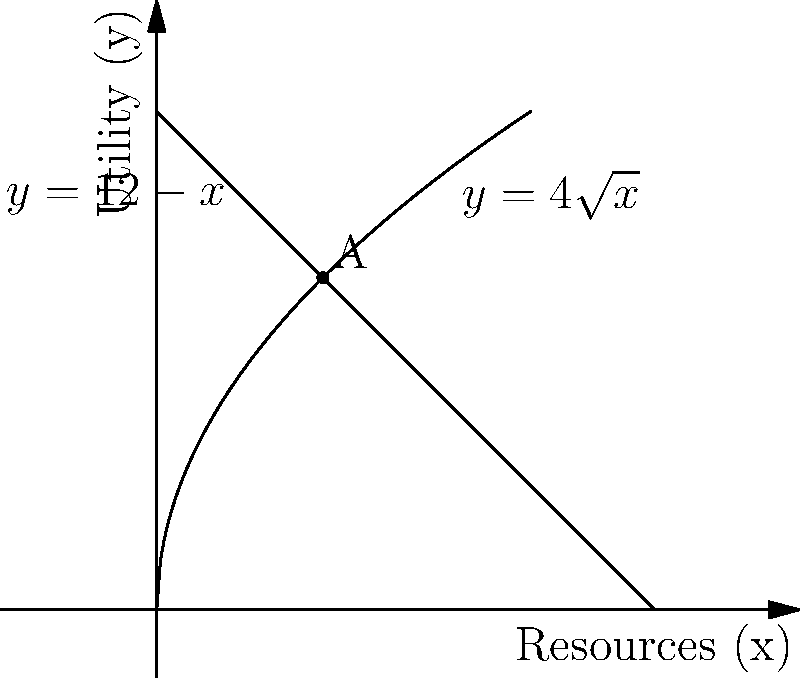A refugee center needs to distribute resources efficiently. The utility derived from distributing $x$ units of resources is given by $y=4\sqrt{x}$, while the cost of resources is represented by $y=12-x$. At what point should resources be distributed to maximize net utility, and what is the maximum net utility achieved? To solve this problem, we need to follow these steps:

1) The point of optimal distribution is where the marginal utility equals the marginal cost. This occurs at the intersection of the two curves.

2) To find the intersection, set the equations equal:

   $4\sqrt{x} = 12-x$

3) Rearrange the equation:

   $4\sqrt{x} + x = 12$

4) Let $u = \sqrt{x}$. Then $x = u^2$, and our equation becomes:

   $4u + u^2 = 12$

5) Rearrange to standard quadratic form:

   $u^2 + 4u - 12 = 0$

6) Solve using the quadratic formula: $u = \frac{-4 \pm \sqrt{16+48}}{2} = \frac{-4 \pm \sqrt{64}}{2} = \frac{-4 \pm 8}{2}$

7) The positive solution is $u = 2$. Since $u = \sqrt{x}$, $x = 4$.

8) The optimal point is at $(4, 8)$ on both curves.

9) The net utility is the difference between the utility curve and the cost curve at this point:

   Net Utility = $4\sqrt{4} - (12-4) = 8 - 8 = 0$

Therefore, the optimal distribution is 4 units of resources, achieving a maximum net utility of 0.
Answer: Optimal distribution: 4 units; Maximum net utility: 0 